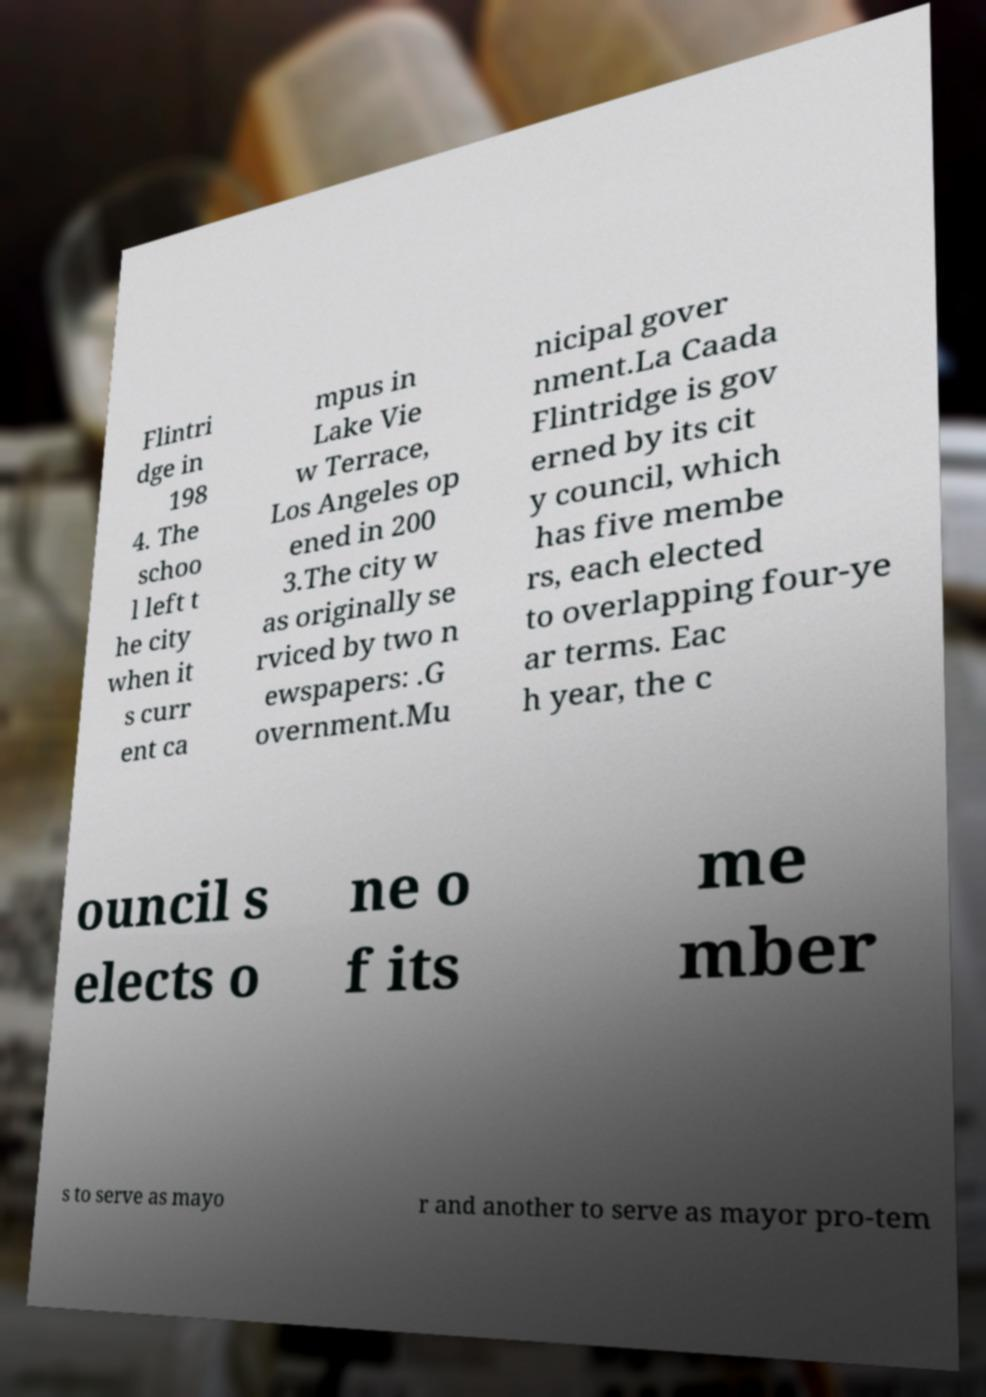Could you extract and type out the text from this image? Flintri dge in 198 4. The schoo l left t he city when it s curr ent ca mpus in Lake Vie w Terrace, Los Angeles op ened in 200 3.The city w as originally se rviced by two n ewspapers: .G overnment.Mu nicipal gover nment.La Caada Flintridge is gov erned by its cit y council, which has five membe rs, each elected to overlapping four-ye ar terms. Eac h year, the c ouncil s elects o ne o f its me mber s to serve as mayo r and another to serve as mayor pro-tem 